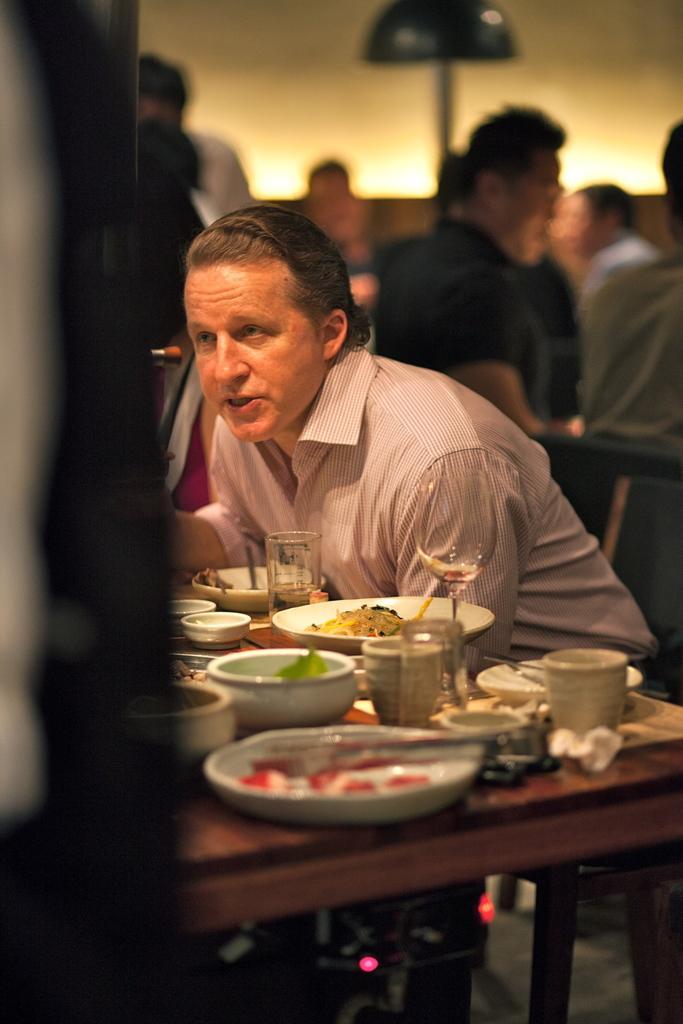Describe this image in one or two sentences. On the background we can see a wall and few persons sitting and standing. In Front portion of the picture we can see a man sitting on a chair in front of a dining table and on the dining table we can see plate of food, bowl, glasses, cup, tissue paper. This is a floor. 